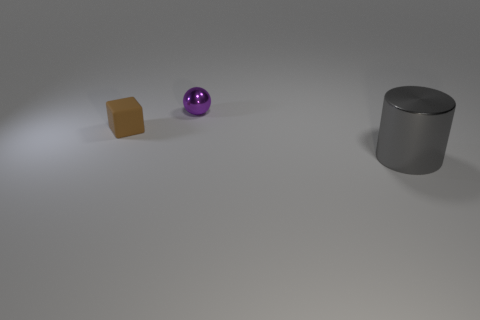Add 1 small things. How many objects exist? 4 Subtract all cylinders. How many objects are left? 2 Subtract all small blue cubes. Subtract all small purple shiny things. How many objects are left? 2 Add 3 tiny metallic things. How many tiny metallic things are left? 4 Add 3 big green shiny cylinders. How many big green shiny cylinders exist? 3 Subtract 0 yellow cylinders. How many objects are left? 3 